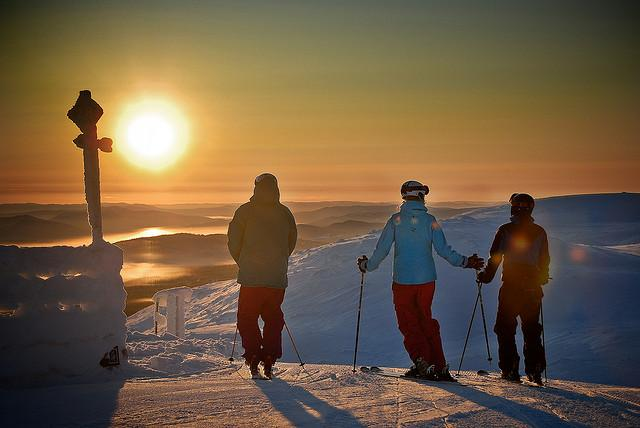What are the skiers watching? Please explain your reasoning. sun. The skiers are looking at the sun. 